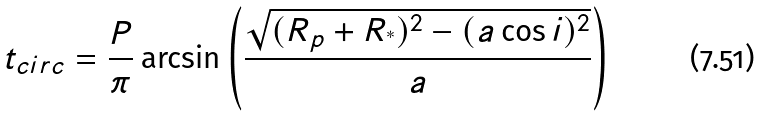<formula> <loc_0><loc_0><loc_500><loc_500>t _ { c i r c } = \frac { P } { \pi } \arcsin \left ( \frac { \sqrt { ( R _ { p } + R _ { ^ { * } } ) ^ { 2 } - ( a \cos i ) ^ { 2 } } } { a } \right )</formula> 